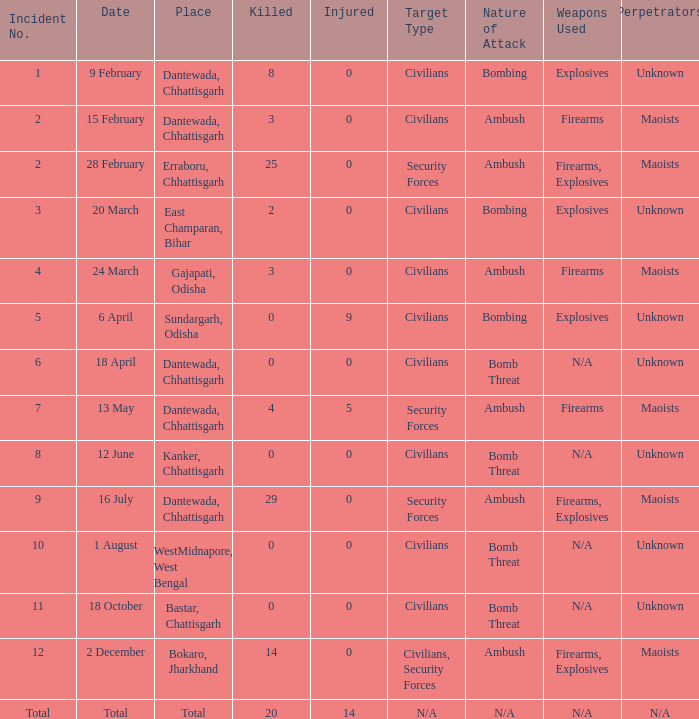What is the least amount of injuries in Dantewada, Chhattisgarh when 8 people were killed? 0.0. 